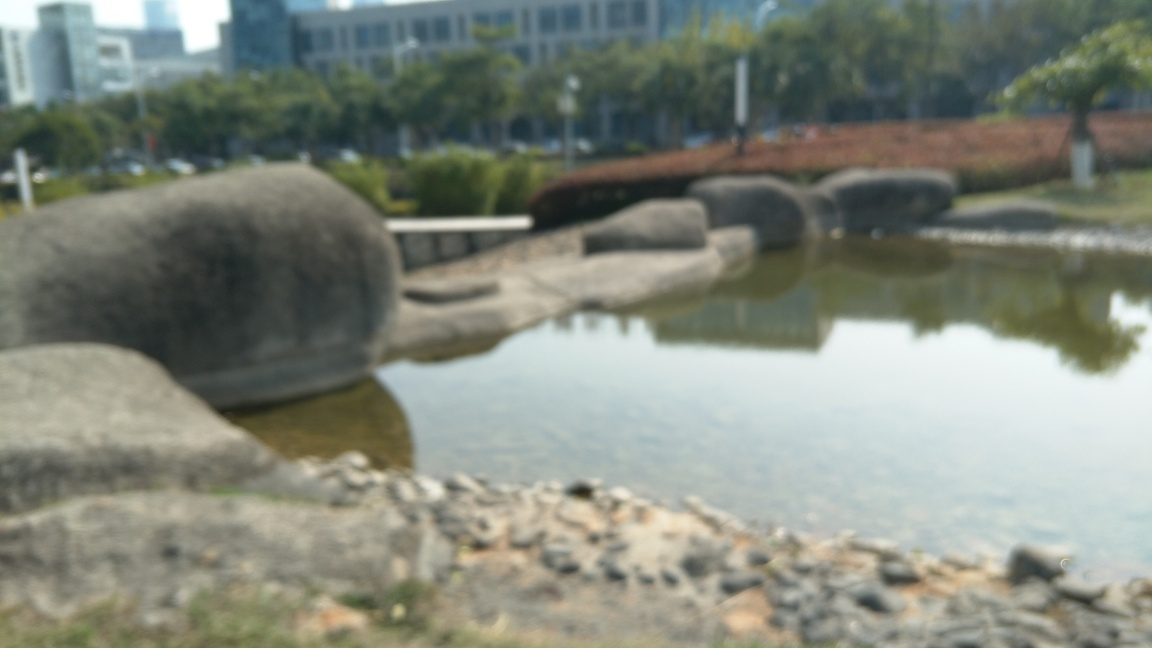Can you describe the setting and overall atmosphere presented in the image? The image depicts an outdoor scene with large sculptural elements that resemble elongated, smooth stones or artistic sculptures, resting by a calm body of water, possibly a pond or a lake. The setting includes some urban elements in the blurred background, suggesting the presence of a park within a city. Due to the blurriness of the image, there is an ethereal, dreamlike quality that envelops the atmosphere, creating a serene and somewhat mysterious environment. 